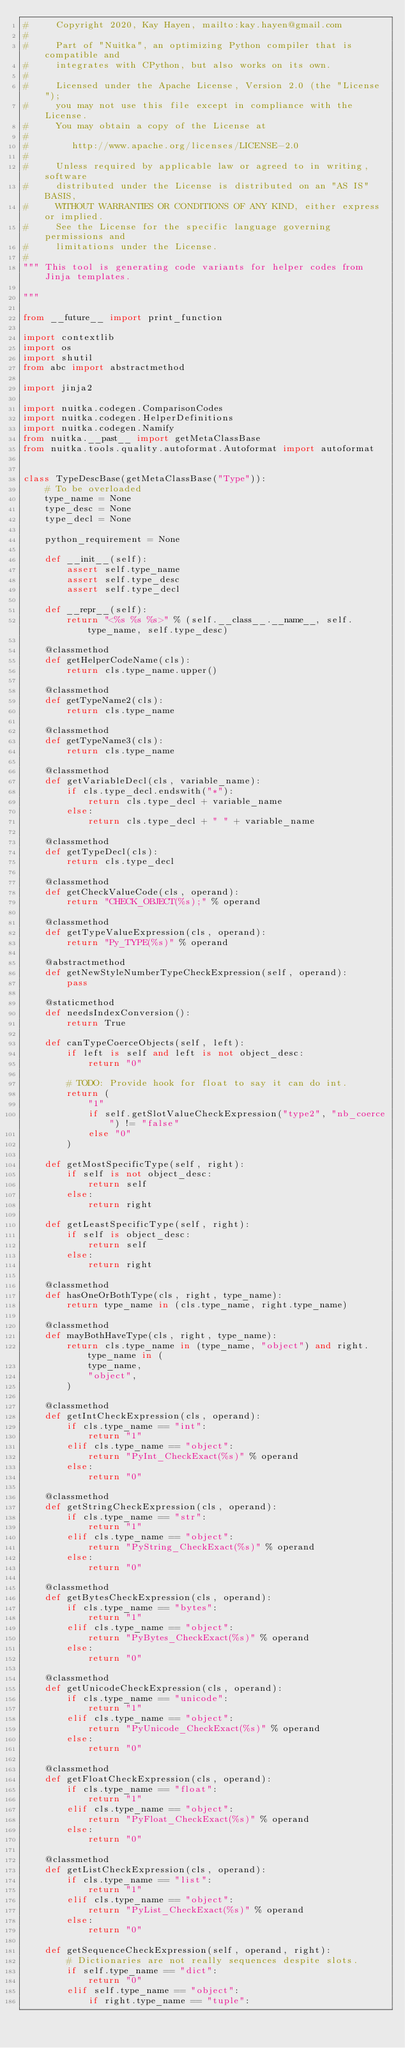Convert code to text. <code><loc_0><loc_0><loc_500><loc_500><_Python_>#     Copyright 2020, Kay Hayen, mailto:kay.hayen@gmail.com
#
#     Part of "Nuitka", an optimizing Python compiler that is compatible and
#     integrates with CPython, but also works on its own.
#
#     Licensed under the Apache License, Version 2.0 (the "License");
#     you may not use this file except in compliance with the License.
#     You may obtain a copy of the License at
#
#        http://www.apache.org/licenses/LICENSE-2.0
#
#     Unless required by applicable law or agreed to in writing, software
#     distributed under the License is distributed on an "AS IS" BASIS,
#     WITHOUT WARRANTIES OR CONDITIONS OF ANY KIND, either express or implied.
#     See the License for the specific language governing permissions and
#     limitations under the License.
#
""" This tool is generating code variants for helper codes from Jinja templates.

"""

from __future__ import print_function

import contextlib
import os
import shutil
from abc import abstractmethod

import jinja2

import nuitka.codegen.ComparisonCodes
import nuitka.codegen.HelperDefinitions
import nuitka.codegen.Namify
from nuitka.__past__ import getMetaClassBase
from nuitka.tools.quality.autoformat.Autoformat import autoformat


class TypeDescBase(getMetaClassBase("Type")):
    # To be overloaded
    type_name = None
    type_desc = None
    type_decl = None

    python_requirement = None

    def __init__(self):
        assert self.type_name
        assert self.type_desc
        assert self.type_decl

    def __repr__(self):
        return "<%s %s %s>" % (self.__class__.__name__, self.type_name, self.type_desc)

    @classmethod
    def getHelperCodeName(cls):
        return cls.type_name.upper()

    @classmethod
    def getTypeName2(cls):
        return cls.type_name

    @classmethod
    def getTypeName3(cls):
        return cls.type_name

    @classmethod
    def getVariableDecl(cls, variable_name):
        if cls.type_decl.endswith("*"):
            return cls.type_decl + variable_name
        else:
            return cls.type_decl + " " + variable_name

    @classmethod
    def getTypeDecl(cls):
        return cls.type_decl

    @classmethod
    def getCheckValueCode(cls, operand):
        return "CHECK_OBJECT(%s);" % operand

    @classmethod
    def getTypeValueExpression(cls, operand):
        return "Py_TYPE(%s)" % operand

    @abstractmethod
    def getNewStyleNumberTypeCheckExpression(self, operand):
        pass

    @staticmethod
    def needsIndexConversion():
        return True

    def canTypeCoerceObjects(self, left):
        if left is self and left is not object_desc:
            return "0"

        # TODO: Provide hook for float to say it can do int.
        return (
            "1"
            if self.getSlotValueCheckExpression("type2", "nb_coerce") != "false"
            else "0"
        )

    def getMostSpecificType(self, right):
        if self is not object_desc:
            return self
        else:
            return right

    def getLeastSpecificType(self, right):
        if self is object_desc:
            return self
        else:
            return right

    @classmethod
    def hasOneOrBothType(cls, right, type_name):
        return type_name in (cls.type_name, right.type_name)

    @classmethod
    def mayBothHaveType(cls, right, type_name):
        return cls.type_name in (type_name, "object") and right.type_name in (
            type_name,
            "object",
        )

    @classmethod
    def getIntCheckExpression(cls, operand):
        if cls.type_name == "int":
            return "1"
        elif cls.type_name == "object":
            return "PyInt_CheckExact(%s)" % operand
        else:
            return "0"

    @classmethod
    def getStringCheckExpression(cls, operand):
        if cls.type_name == "str":
            return "1"
        elif cls.type_name == "object":
            return "PyString_CheckExact(%s)" % operand
        else:
            return "0"

    @classmethod
    def getBytesCheckExpression(cls, operand):
        if cls.type_name == "bytes":
            return "1"
        elif cls.type_name == "object":
            return "PyBytes_CheckExact(%s)" % operand
        else:
            return "0"

    @classmethod
    def getUnicodeCheckExpression(cls, operand):
        if cls.type_name == "unicode":
            return "1"
        elif cls.type_name == "object":
            return "PyUnicode_CheckExact(%s)" % operand
        else:
            return "0"

    @classmethod
    def getFloatCheckExpression(cls, operand):
        if cls.type_name == "float":
            return "1"
        elif cls.type_name == "object":
            return "PyFloat_CheckExact(%s)" % operand
        else:
            return "0"

    @classmethod
    def getListCheckExpression(cls, operand):
        if cls.type_name == "list":
            return "1"
        elif cls.type_name == "object":
            return "PyList_CheckExact(%s)" % operand
        else:
            return "0"

    def getSequenceCheckExpression(self, operand, right):
        # Dictionaries are not really sequences despite slots.
        if self.type_name == "dict":
            return "0"
        elif self.type_name == "object":
            if right.type_name == "tuple":</code> 